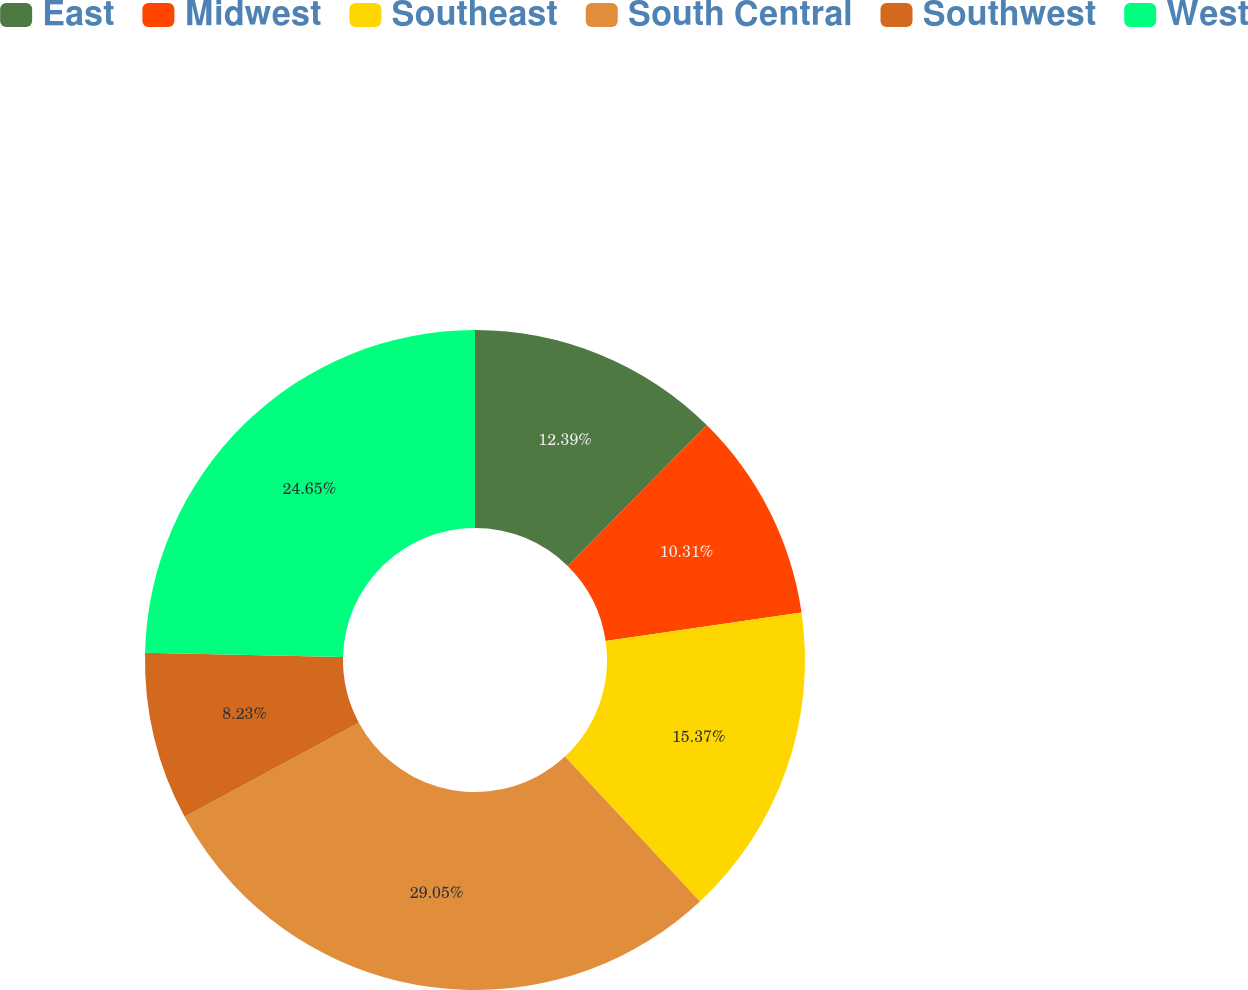Convert chart to OTSL. <chart><loc_0><loc_0><loc_500><loc_500><pie_chart><fcel>East<fcel>Midwest<fcel>Southeast<fcel>South Central<fcel>Southwest<fcel>West<nl><fcel>12.39%<fcel>10.31%<fcel>15.37%<fcel>29.06%<fcel>8.23%<fcel>24.65%<nl></chart> 